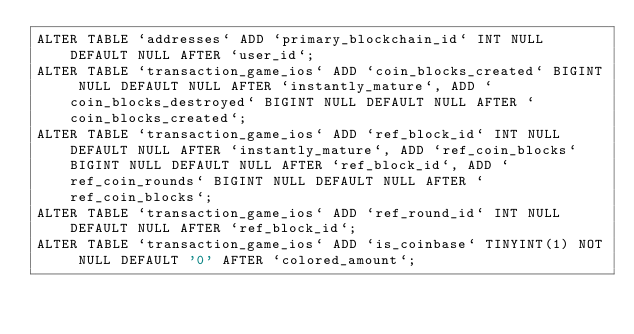<code> <loc_0><loc_0><loc_500><loc_500><_SQL_>ALTER TABLE `addresses` ADD `primary_blockchain_id` INT NULL DEFAULT NULL AFTER `user_id`;
ALTER TABLE `transaction_game_ios` ADD `coin_blocks_created` BIGINT NULL DEFAULT NULL AFTER `instantly_mature`, ADD `coin_blocks_destroyed` BIGINT NULL DEFAULT NULL AFTER `coin_blocks_created`;
ALTER TABLE `transaction_game_ios` ADD `ref_block_id` INT NULL DEFAULT NULL AFTER `instantly_mature`, ADD `ref_coin_blocks` BIGINT NULL DEFAULT NULL AFTER `ref_block_id`, ADD `ref_coin_rounds` BIGINT NULL DEFAULT NULL AFTER `ref_coin_blocks`;
ALTER TABLE `transaction_game_ios` ADD `ref_round_id` INT NULL DEFAULT NULL AFTER `ref_block_id`;
ALTER TABLE `transaction_game_ios` ADD `is_coinbase` TINYINT(1) NOT NULL DEFAULT '0' AFTER `colored_amount`;</code> 